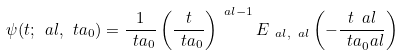<formula> <loc_0><loc_0><loc_500><loc_500>\psi ( t ; \ a l , \ t a _ { 0 } ) = \frac { 1 } { \ t a _ { 0 } } \left ( \frac { t } { \ t a _ { 0 } } \right ) ^ { \ a l - 1 } E _ { \ a l , \ a l } \left ( - \frac { t ^ { \ } a l } { \ t a _ { 0 } ^ { \ } a l } \right )</formula> 